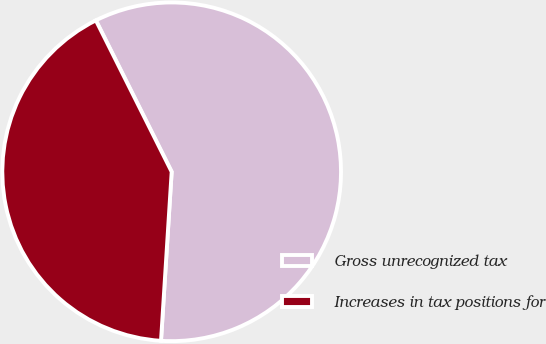Convert chart to OTSL. <chart><loc_0><loc_0><loc_500><loc_500><pie_chart><fcel>Gross unrecognized tax<fcel>Increases in tax positions for<nl><fcel>58.39%<fcel>41.61%<nl></chart> 